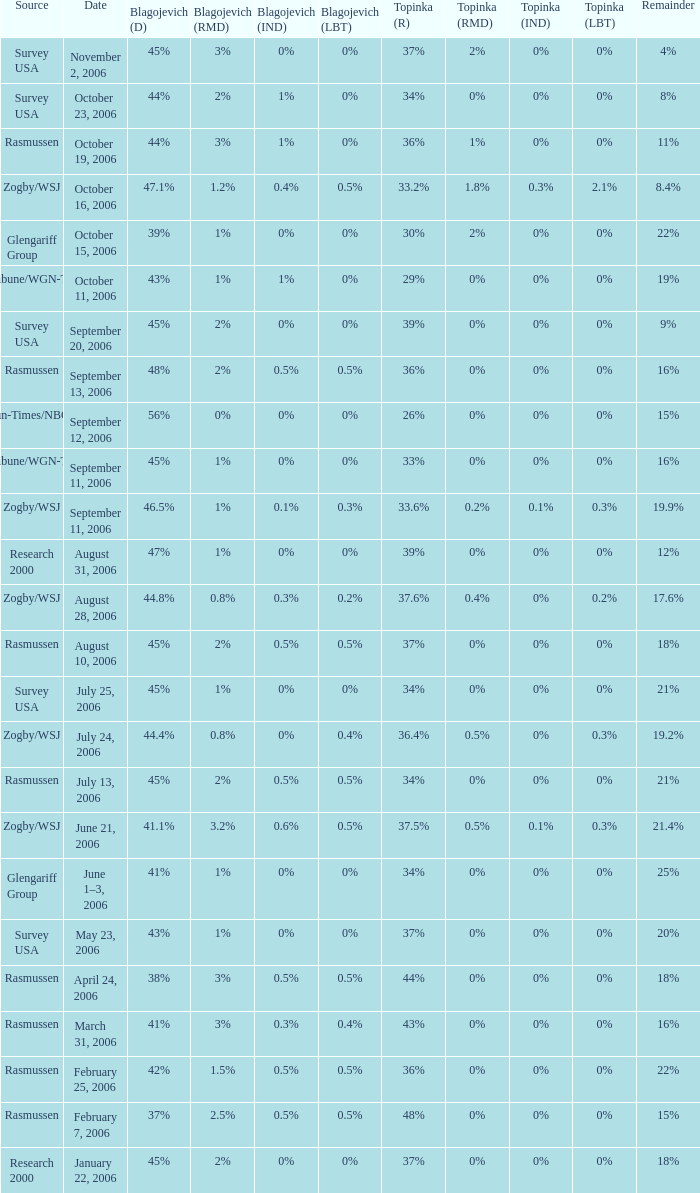Which blagojevich (d) features a zogby/wsj basis and a topinka (r) of 3 47.1%. 